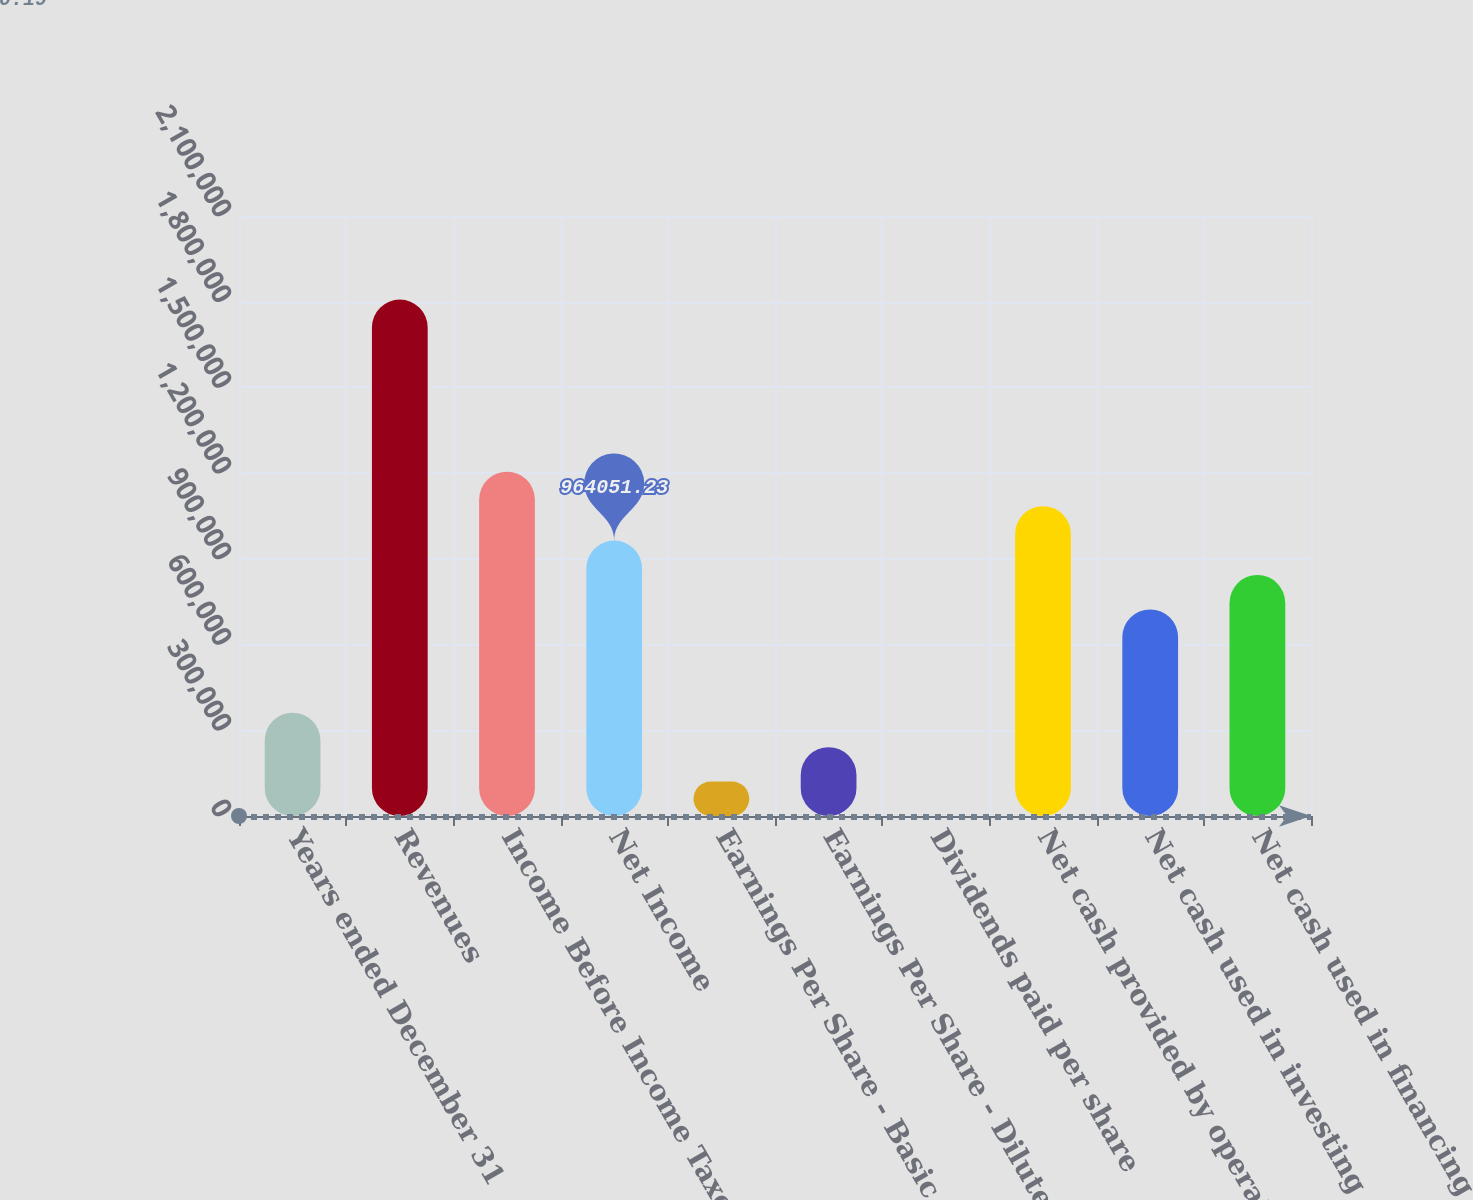Convert chart to OTSL. <chart><loc_0><loc_0><loc_500><loc_500><bar_chart><fcel>Years ended December 31<fcel>Revenues<fcel>Income Before Income Taxes<fcel>Net Income<fcel>Earnings Per Share - Basic<fcel>Earnings Per Share - Diluted<fcel>Dividends paid per share<fcel>Net cash provided by operating<fcel>Net cash used in investing<fcel>Net cash used in financing<nl><fcel>361519<fcel>1.8076e+06<fcel>1.20506e+06<fcel>964051<fcel>120507<fcel>241013<fcel>0.19<fcel>1.08456e+06<fcel>723038<fcel>843545<nl></chart> 